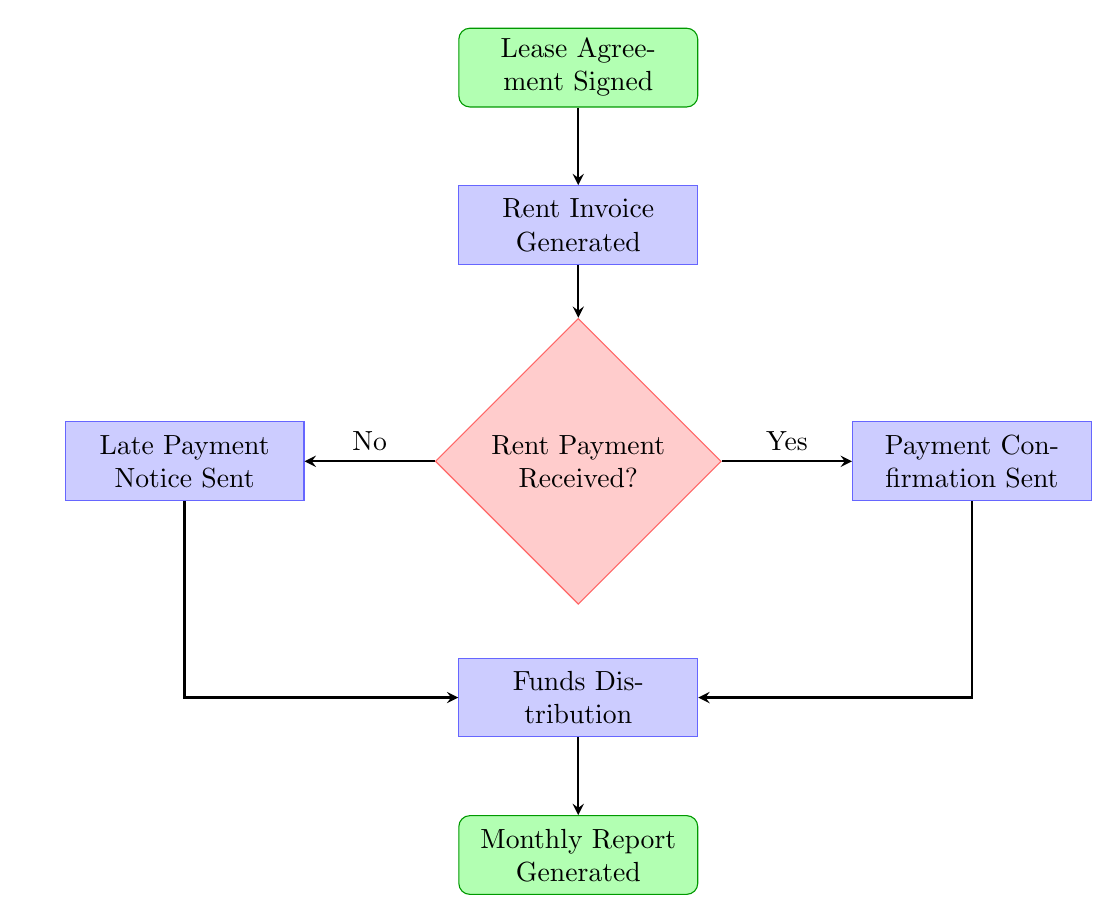What is the first step in the rent collection process? The first step, as indicated in the diagram, is "Lease Agreement Signed," which captures the initiation of the rent collection process between the tenant and the property management company.
Answer: Lease Agreement Signed How many distinct processes are in the flow chart? Analyzing the diagram reveals there are four distinct processes: "Rent Invoice Generated," "Payment Confirmation Sent," "Late Payment Notice Sent," and "Funds Distribution." Counting these processes gives a total of four.
Answer: Four What happens if the rent payment is not received? If the rent payment is not received, as per the decision node labeled "Rent Payment Received?", a "Late Payment Notice Sent" process is initiated, notifying the tenant of the missed payment.
Answer: Late Payment Notice Sent Which node directly follows the payment confirmation step? Following the "Payment Confirmation Sent," the next step in the process flow is "Funds Distribution," indicating where money is allocated after confirming payment.
Answer: Funds Distribution What node generates a report after funds distribution? After the "Funds Distribution" process, the final step in the flow is the generation of a report, as indicated by the "Monthly Report Generated" node, providing summary details to the overseas investor.
Answer: Monthly Report Generated How many decision nodes are in the diagram? The diagram includes one decision node, which is "Rent Payment Received?" This node determines the flow based on whether the rent payment has been confirmed or not.
Answer: One If the payment is confirmed, what is the next action taken? When the payment is confirmed ("Yes" condition from the decision node), the next action taken is sending a "Payment Confirmation Sent" to notify the tenant, and this leads to "Funds Distribution."
Answer: Funds Distribution What is the output of the process after funds distribution is complete? The output after completing the "Funds Distribution" process is the generation of a "Monthly Report Generated," ensuring that the overseas investor receives financial updates.
Answer: Monthly Report Generated 